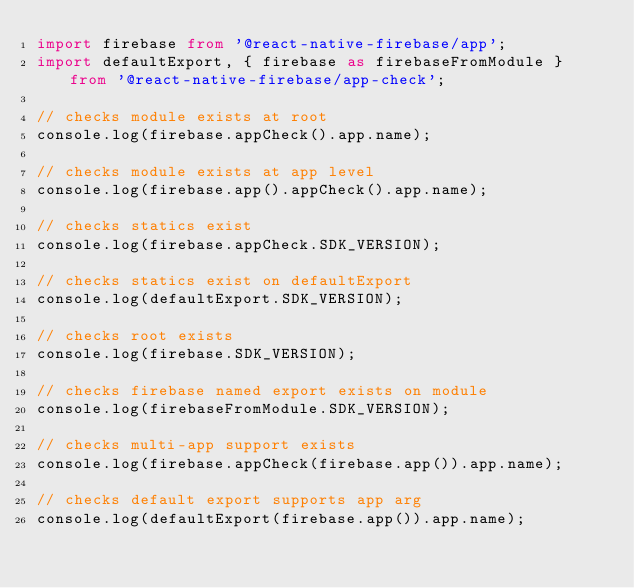Convert code to text. <code><loc_0><loc_0><loc_500><loc_500><_TypeScript_>import firebase from '@react-native-firebase/app';
import defaultExport, { firebase as firebaseFromModule } from '@react-native-firebase/app-check';

// checks module exists at root
console.log(firebase.appCheck().app.name);

// checks module exists at app level
console.log(firebase.app().appCheck().app.name);

// checks statics exist
console.log(firebase.appCheck.SDK_VERSION);

// checks statics exist on defaultExport
console.log(defaultExport.SDK_VERSION);

// checks root exists
console.log(firebase.SDK_VERSION);

// checks firebase named export exists on module
console.log(firebaseFromModule.SDK_VERSION);

// checks multi-app support exists
console.log(firebase.appCheck(firebase.app()).app.name);

// checks default export supports app arg
console.log(defaultExport(firebase.app()).app.name);
</code> 